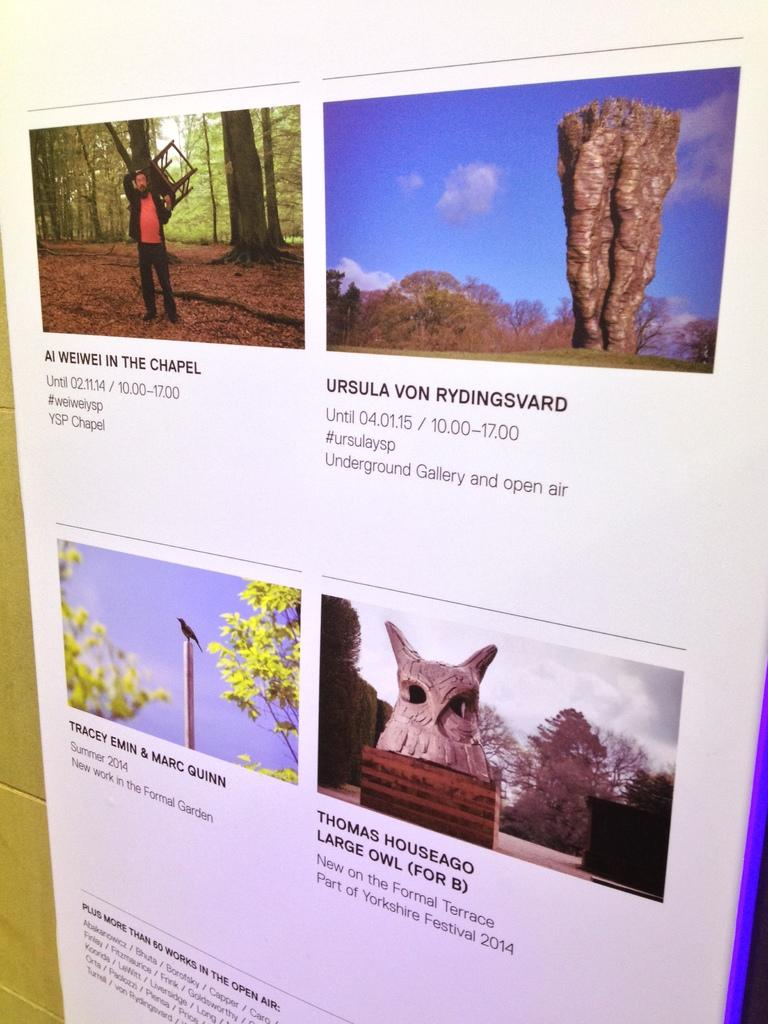What is on the wall in the image? There is a display board on the wall in the image. What can be found on the display board? The display board contains photographs and text. What type of flag is being waved by the father in the image? There is no father or flag present in the image; it only features a display board with photographs and text. 